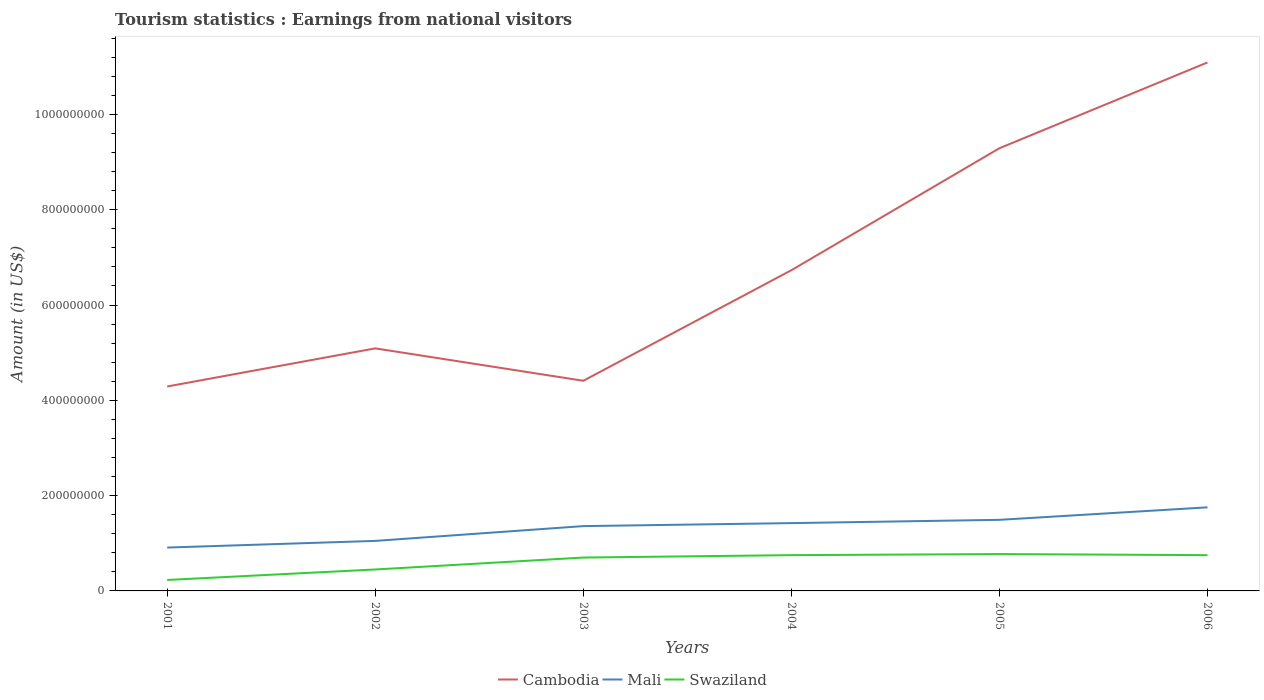Does the line corresponding to Swaziland intersect with the line corresponding to Mali?
Provide a short and direct response. No. Across all years, what is the maximum earnings from national visitors in Cambodia?
Your response must be concise. 4.29e+08. What is the total earnings from national visitors in Cambodia in the graph?
Give a very brief answer. -1.20e+07. What is the difference between the highest and the second highest earnings from national visitors in Mali?
Ensure brevity in your answer.  8.44e+07. Is the earnings from national visitors in Swaziland strictly greater than the earnings from national visitors in Cambodia over the years?
Offer a terse response. Yes. How many lines are there?
Provide a short and direct response. 3. How many years are there in the graph?
Offer a terse response. 6. How are the legend labels stacked?
Your answer should be compact. Horizontal. What is the title of the graph?
Your answer should be very brief. Tourism statistics : Earnings from national visitors. What is the Amount (in US$) in Cambodia in 2001?
Your response must be concise. 4.29e+08. What is the Amount (in US$) of Mali in 2001?
Make the answer very short. 9.10e+07. What is the Amount (in US$) in Swaziland in 2001?
Provide a succinct answer. 2.30e+07. What is the Amount (in US$) of Cambodia in 2002?
Keep it short and to the point. 5.09e+08. What is the Amount (in US$) in Mali in 2002?
Offer a terse response. 1.05e+08. What is the Amount (in US$) in Swaziland in 2002?
Make the answer very short. 4.50e+07. What is the Amount (in US$) of Cambodia in 2003?
Your answer should be compact. 4.41e+08. What is the Amount (in US$) of Mali in 2003?
Keep it short and to the point. 1.36e+08. What is the Amount (in US$) of Swaziland in 2003?
Provide a succinct answer. 7.00e+07. What is the Amount (in US$) of Cambodia in 2004?
Give a very brief answer. 6.73e+08. What is the Amount (in US$) of Mali in 2004?
Your answer should be compact. 1.42e+08. What is the Amount (in US$) of Swaziland in 2004?
Your response must be concise. 7.51e+07. What is the Amount (in US$) of Cambodia in 2005?
Your answer should be compact. 9.29e+08. What is the Amount (in US$) of Mali in 2005?
Your response must be concise. 1.49e+08. What is the Amount (in US$) in Swaziland in 2005?
Provide a succinct answer. 7.73e+07. What is the Amount (in US$) in Cambodia in 2006?
Offer a terse response. 1.11e+09. What is the Amount (in US$) in Mali in 2006?
Give a very brief answer. 1.75e+08. What is the Amount (in US$) of Swaziland in 2006?
Ensure brevity in your answer.  7.51e+07. Across all years, what is the maximum Amount (in US$) of Cambodia?
Offer a very short reply. 1.11e+09. Across all years, what is the maximum Amount (in US$) in Mali?
Your answer should be compact. 1.75e+08. Across all years, what is the maximum Amount (in US$) in Swaziland?
Your answer should be very brief. 7.73e+07. Across all years, what is the minimum Amount (in US$) of Cambodia?
Offer a very short reply. 4.29e+08. Across all years, what is the minimum Amount (in US$) in Mali?
Keep it short and to the point. 9.10e+07. Across all years, what is the minimum Amount (in US$) of Swaziland?
Your answer should be compact. 2.30e+07. What is the total Amount (in US$) of Cambodia in the graph?
Your answer should be very brief. 4.09e+09. What is the total Amount (in US$) of Mali in the graph?
Offer a very short reply. 7.99e+08. What is the total Amount (in US$) in Swaziland in the graph?
Your answer should be very brief. 3.66e+08. What is the difference between the Amount (in US$) of Cambodia in 2001 and that in 2002?
Offer a terse response. -8.00e+07. What is the difference between the Amount (in US$) of Mali in 2001 and that in 2002?
Keep it short and to the point. -1.40e+07. What is the difference between the Amount (in US$) in Swaziland in 2001 and that in 2002?
Your answer should be very brief. -2.20e+07. What is the difference between the Amount (in US$) in Cambodia in 2001 and that in 2003?
Give a very brief answer. -1.20e+07. What is the difference between the Amount (in US$) in Mali in 2001 and that in 2003?
Keep it short and to the point. -4.50e+07. What is the difference between the Amount (in US$) of Swaziland in 2001 and that in 2003?
Offer a terse response. -4.70e+07. What is the difference between the Amount (in US$) in Cambodia in 2001 and that in 2004?
Your answer should be compact. -2.44e+08. What is the difference between the Amount (in US$) in Mali in 2001 and that in 2004?
Provide a succinct answer. -5.13e+07. What is the difference between the Amount (in US$) in Swaziland in 2001 and that in 2004?
Make the answer very short. -5.21e+07. What is the difference between the Amount (in US$) in Cambodia in 2001 and that in 2005?
Offer a very short reply. -5.00e+08. What is the difference between the Amount (in US$) in Mali in 2001 and that in 2005?
Your response must be concise. -5.82e+07. What is the difference between the Amount (in US$) in Swaziland in 2001 and that in 2005?
Give a very brief answer. -5.43e+07. What is the difference between the Amount (in US$) of Cambodia in 2001 and that in 2006?
Provide a short and direct response. -6.80e+08. What is the difference between the Amount (in US$) in Mali in 2001 and that in 2006?
Your answer should be compact. -8.44e+07. What is the difference between the Amount (in US$) of Swaziland in 2001 and that in 2006?
Offer a very short reply. -5.21e+07. What is the difference between the Amount (in US$) of Cambodia in 2002 and that in 2003?
Keep it short and to the point. 6.80e+07. What is the difference between the Amount (in US$) of Mali in 2002 and that in 2003?
Make the answer very short. -3.10e+07. What is the difference between the Amount (in US$) of Swaziland in 2002 and that in 2003?
Your response must be concise. -2.50e+07. What is the difference between the Amount (in US$) in Cambodia in 2002 and that in 2004?
Your response must be concise. -1.64e+08. What is the difference between the Amount (in US$) in Mali in 2002 and that in 2004?
Provide a succinct answer. -3.73e+07. What is the difference between the Amount (in US$) of Swaziland in 2002 and that in 2004?
Provide a short and direct response. -3.01e+07. What is the difference between the Amount (in US$) of Cambodia in 2002 and that in 2005?
Give a very brief answer. -4.20e+08. What is the difference between the Amount (in US$) in Mali in 2002 and that in 2005?
Provide a short and direct response. -4.42e+07. What is the difference between the Amount (in US$) in Swaziland in 2002 and that in 2005?
Provide a succinct answer. -3.23e+07. What is the difference between the Amount (in US$) in Cambodia in 2002 and that in 2006?
Provide a succinct answer. -6.00e+08. What is the difference between the Amount (in US$) in Mali in 2002 and that in 2006?
Keep it short and to the point. -7.04e+07. What is the difference between the Amount (in US$) of Swaziland in 2002 and that in 2006?
Provide a succinct answer. -3.01e+07. What is the difference between the Amount (in US$) of Cambodia in 2003 and that in 2004?
Offer a terse response. -2.32e+08. What is the difference between the Amount (in US$) in Mali in 2003 and that in 2004?
Offer a terse response. -6.30e+06. What is the difference between the Amount (in US$) in Swaziland in 2003 and that in 2004?
Provide a short and direct response. -5.06e+06. What is the difference between the Amount (in US$) of Cambodia in 2003 and that in 2005?
Give a very brief answer. -4.88e+08. What is the difference between the Amount (in US$) in Mali in 2003 and that in 2005?
Give a very brief answer. -1.32e+07. What is the difference between the Amount (in US$) of Swaziland in 2003 and that in 2005?
Offer a very short reply. -7.26e+06. What is the difference between the Amount (in US$) of Cambodia in 2003 and that in 2006?
Provide a succinct answer. -6.68e+08. What is the difference between the Amount (in US$) in Mali in 2003 and that in 2006?
Ensure brevity in your answer.  -3.94e+07. What is the difference between the Amount (in US$) in Swaziland in 2003 and that in 2006?
Ensure brevity in your answer.  -5.06e+06. What is the difference between the Amount (in US$) of Cambodia in 2004 and that in 2005?
Your answer should be very brief. -2.56e+08. What is the difference between the Amount (in US$) in Mali in 2004 and that in 2005?
Provide a short and direct response. -6.90e+06. What is the difference between the Amount (in US$) of Swaziland in 2004 and that in 2005?
Make the answer very short. -2.20e+06. What is the difference between the Amount (in US$) in Cambodia in 2004 and that in 2006?
Offer a terse response. -4.36e+08. What is the difference between the Amount (in US$) in Mali in 2004 and that in 2006?
Ensure brevity in your answer.  -3.31e+07. What is the difference between the Amount (in US$) in Swaziland in 2004 and that in 2006?
Give a very brief answer. 0. What is the difference between the Amount (in US$) in Cambodia in 2005 and that in 2006?
Give a very brief answer. -1.80e+08. What is the difference between the Amount (in US$) in Mali in 2005 and that in 2006?
Make the answer very short. -2.62e+07. What is the difference between the Amount (in US$) in Swaziland in 2005 and that in 2006?
Your response must be concise. 2.20e+06. What is the difference between the Amount (in US$) of Cambodia in 2001 and the Amount (in US$) of Mali in 2002?
Provide a short and direct response. 3.24e+08. What is the difference between the Amount (in US$) in Cambodia in 2001 and the Amount (in US$) in Swaziland in 2002?
Your answer should be compact. 3.84e+08. What is the difference between the Amount (in US$) in Mali in 2001 and the Amount (in US$) in Swaziland in 2002?
Your answer should be very brief. 4.60e+07. What is the difference between the Amount (in US$) in Cambodia in 2001 and the Amount (in US$) in Mali in 2003?
Offer a terse response. 2.93e+08. What is the difference between the Amount (in US$) in Cambodia in 2001 and the Amount (in US$) in Swaziland in 2003?
Make the answer very short. 3.59e+08. What is the difference between the Amount (in US$) in Mali in 2001 and the Amount (in US$) in Swaziland in 2003?
Keep it short and to the point. 2.10e+07. What is the difference between the Amount (in US$) of Cambodia in 2001 and the Amount (in US$) of Mali in 2004?
Provide a succinct answer. 2.87e+08. What is the difference between the Amount (in US$) in Cambodia in 2001 and the Amount (in US$) in Swaziland in 2004?
Provide a succinct answer. 3.54e+08. What is the difference between the Amount (in US$) of Mali in 2001 and the Amount (in US$) of Swaziland in 2004?
Your response must be concise. 1.59e+07. What is the difference between the Amount (in US$) of Cambodia in 2001 and the Amount (in US$) of Mali in 2005?
Give a very brief answer. 2.80e+08. What is the difference between the Amount (in US$) in Cambodia in 2001 and the Amount (in US$) in Swaziland in 2005?
Your answer should be compact. 3.52e+08. What is the difference between the Amount (in US$) of Mali in 2001 and the Amount (in US$) of Swaziland in 2005?
Your response must be concise. 1.37e+07. What is the difference between the Amount (in US$) in Cambodia in 2001 and the Amount (in US$) in Mali in 2006?
Give a very brief answer. 2.54e+08. What is the difference between the Amount (in US$) in Cambodia in 2001 and the Amount (in US$) in Swaziland in 2006?
Make the answer very short. 3.54e+08. What is the difference between the Amount (in US$) in Mali in 2001 and the Amount (in US$) in Swaziland in 2006?
Offer a very short reply. 1.59e+07. What is the difference between the Amount (in US$) of Cambodia in 2002 and the Amount (in US$) of Mali in 2003?
Keep it short and to the point. 3.73e+08. What is the difference between the Amount (in US$) in Cambodia in 2002 and the Amount (in US$) in Swaziland in 2003?
Ensure brevity in your answer.  4.39e+08. What is the difference between the Amount (in US$) in Mali in 2002 and the Amount (in US$) in Swaziland in 2003?
Provide a short and direct response. 3.50e+07. What is the difference between the Amount (in US$) in Cambodia in 2002 and the Amount (in US$) in Mali in 2004?
Your answer should be compact. 3.67e+08. What is the difference between the Amount (in US$) in Cambodia in 2002 and the Amount (in US$) in Swaziland in 2004?
Give a very brief answer. 4.34e+08. What is the difference between the Amount (in US$) in Mali in 2002 and the Amount (in US$) in Swaziland in 2004?
Offer a terse response. 2.99e+07. What is the difference between the Amount (in US$) of Cambodia in 2002 and the Amount (in US$) of Mali in 2005?
Your response must be concise. 3.60e+08. What is the difference between the Amount (in US$) in Cambodia in 2002 and the Amount (in US$) in Swaziland in 2005?
Ensure brevity in your answer.  4.32e+08. What is the difference between the Amount (in US$) of Mali in 2002 and the Amount (in US$) of Swaziland in 2005?
Offer a terse response. 2.77e+07. What is the difference between the Amount (in US$) of Cambodia in 2002 and the Amount (in US$) of Mali in 2006?
Your answer should be compact. 3.34e+08. What is the difference between the Amount (in US$) of Cambodia in 2002 and the Amount (in US$) of Swaziland in 2006?
Offer a very short reply. 4.34e+08. What is the difference between the Amount (in US$) in Mali in 2002 and the Amount (in US$) in Swaziland in 2006?
Ensure brevity in your answer.  2.99e+07. What is the difference between the Amount (in US$) in Cambodia in 2003 and the Amount (in US$) in Mali in 2004?
Offer a terse response. 2.99e+08. What is the difference between the Amount (in US$) in Cambodia in 2003 and the Amount (in US$) in Swaziland in 2004?
Provide a short and direct response. 3.66e+08. What is the difference between the Amount (in US$) of Mali in 2003 and the Amount (in US$) of Swaziland in 2004?
Your answer should be compact. 6.09e+07. What is the difference between the Amount (in US$) in Cambodia in 2003 and the Amount (in US$) in Mali in 2005?
Your response must be concise. 2.92e+08. What is the difference between the Amount (in US$) in Cambodia in 2003 and the Amount (in US$) in Swaziland in 2005?
Your response must be concise. 3.64e+08. What is the difference between the Amount (in US$) in Mali in 2003 and the Amount (in US$) in Swaziland in 2005?
Ensure brevity in your answer.  5.87e+07. What is the difference between the Amount (in US$) in Cambodia in 2003 and the Amount (in US$) in Mali in 2006?
Offer a very short reply. 2.66e+08. What is the difference between the Amount (in US$) of Cambodia in 2003 and the Amount (in US$) of Swaziland in 2006?
Ensure brevity in your answer.  3.66e+08. What is the difference between the Amount (in US$) of Mali in 2003 and the Amount (in US$) of Swaziland in 2006?
Your response must be concise. 6.09e+07. What is the difference between the Amount (in US$) in Cambodia in 2004 and the Amount (in US$) in Mali in 2005?
Keep it short and to the point. 5.24e+08. What is the difference between the Amount (in US$) in Cambodia in 2004 and the Amount (in US$) in Swaziland in 2005?
Give a very brief answer. 5.96e+08. What is the difference between the Amount (in US$) of Mali in 2004 and the Amount (in US$) of Swaziland in 2005?
Your answer should be compact. 6.50e+07. What is the difference between the Amount (in US$) in Cambodia in 2004 and the Amount (in US$) in Mali in 2006?
Offer a terse response. 4.98e+08. What is the difference between the Amount (in US$) of Cambodia in 2004 and the Amount (in US$) of Swaziland in 2006?
Your answer should be very brief. 5.98e+08. What is the difference between the Amount (in US$) in Mali in 2004 and the Amount (in US$) in Swaziland in 2006?
Offer a very short reply. 6.72e+07. What is the difference between the Amount (in US$) of Cambodia in 2005 and the Amount (in US$) of Mali in 2006?
Your response must be concise. 7.54e+08. What is the difference between the Amount (in US$) in Cambodia in 2005 and the Amount (in US$) in Swaziland in 2006?
Provide a succinct answer. 8.54e+08. What is the difference between the Amount (in US$) of Mali in 2005 and the Amount (in US$) of Swaziland in 2006?
Your answer should be compact. 7.41e+07. What is the average Amount (in US$) of Cambodia per year?
Offer a terse response. 6.82e+08. What is the average Amount (in US$) of Mali per year?
Offer a very short reply. 1.33e+08. What is the average Amount (in US$) of Swaziland per year?
Your answer should be compact. 6.09e+07. In the year 2001, what is the difference between the Amount (in US$) in Cambodia and Amount (in US$) in Mali?
Your answer should be very brief. 3.38e+08. In the year 2001, what is the difference between the Amount (in US$) of Cambodia and Amount (in US$) of Swaziland?
Provide a short and direct response. 4.06e+08. In the year 2001, what is the difference between the Amount (in US$) of Mali and Amount (in US$) of Swaziland?
Offer a very short reply. 6.80e+07. In the year 2002, what is the difference between the Amount (in US$) of Cambodia and Amount (in US$) of Mali?
Provide a succinct answer. 4.04e+08. In the year 2002, what is the difference between the Amount (in US$) in Cambodia and Amount (in US$) in Swaziland?
Offer a terse response. 4.64e+08. In the year 2002, what is the difference between the Amount (in US$) of Mali and Amount (in US$) of Swaziland?
Give a very brief answer. 6.00e+07. In the year 2003, what is the difference between the Amount (in US$) of Cambodia and Amount (in US$) of Mali?
Provide a short and direct response. 3.05e+08. In the year 2003, what is the difference between the Amount (in US$) of Cambodia and Amount (in US$) of Swaziland?
Your answer should be very brief. 3.71e+08. In the year 2003, what is the difference between the Amount (in US$) in Mali and Amount (in US$) in Swaziland?
Keep it short and to the point. 6.60e+07. In the year 2004, what is the difference between the Amount (in US$) of Cambodia and Amount (in US$) of Mali?
Provide a succinct answer. 5.31e+08. In the year 2004, what is the difference between the Amount (in US$) of Cambodia and Amount (in US$) of Swaziland?
Ensure brevity in your answer.  5.98e+08. In the year 2004, what is the difference between the Amount (in US$) in Mali and Amount (in US$) in Swaziland?
Provide a short and direct response. 6.72e+07. In the year 2005, what is the difference between the Amount (in US$) in Cambodia and Amount (in US$) in Mali?
Keep it short and to the point. 7.80e+08. In the year 2005, what is the difference between the Amount (in US$) in Cambodia and Amount (in US$) in Swaziland?
Your response must be concise. 8.52e+08. In the year 2005, what is the difference between the Amount (in US$) of Mali and Amount (in US$) of Swaziland?
Make the answer very short. 7.19e+07. In the year 2006, what is the difference between the Amount (in US$) in Cambodia and Amount (in US$) in Mali?
Keep it short and to the point. 9.34e+08. In the year 2006, what is the difference between the Amount (in US$) of Cambodia and Amount (in US$) of Swaziland?
Offer a very short reply. 1.03e+09. In the year 2006, what is the difference between the Amount (in US$) of Mali and Amount (in US$) of Swaziland?
Ensure brevity in your answer.  1.00e+08. What is the ratio of the Amount (in US$) in Cambodia in 2001 to that in 2002?
Offer a very short reply. 0.84. What is the ratio of the Amount (in US$) of Mali in 2001 to that in 2002?
Your response must be concise. 0.87. What is the ratio of the Amount (in US$) of Swaziland in 2001 to that in 2002?
Make the answer very short. 0.51. What is the ratio of the Amount (in US$) of Cambodia in 2001 to that in 2003?
Provide a short and direct response. 0.97. What is the ratio of the Amount (in US$) of Mali in 2001 to that in 2003?
Keep it short and to the point. 0.67. What is the ratio of the Amount (in US$) of Swaziland in 2001 to that in 2003?
Offer a terse response. 0.33. What is the ratio of the Amount (in US$) in Cambodia in 2001 to that in 2004?
Provide a short and direct response. 0.64. What is the ratio of the Amount (in US$) in Mali in 2001 to that in 2004?
Your response must be concise. 0.64. What is the ratio of the Amount (in US$) in Swaziland in 2001 to that in 2004?
Offer a terse response. 0.31. What is the ratio of the Amount (in US$) of Cambodia in 2001 to that in 2005?
Ensure brevity in your answer.  0.46. What is the ratio of the Amount (in US$) in Mali in 2001 to that in 2005?
Make the answer very short. 0.61. What is the ratio of the Amount (in US$) in Swaziland in 2001 to that in 2005?
Offer a very short reply. 0.3. What is the ratio of the Amount (in US$) of Cambodia in 2001 to that in 2006?
Ensure brevity in your answer.  0.39. What is the ratio of the Amount (in US$) of Mali in 2001 to that in 2006?
Your answer should be compact. 0.52. What is the ratio of the Amount (in US$) in Swaziland in 2001 to that in 2006?
Give a very brief answer. 0.31. What is the ratio of the Amount (in US$) of Cambodia in 2002 to that in 2003?
Keep it short and to the point. 1.15. What is the ratio of the Amount (in US$) of Mali in 2002 to that in 2003?
Your answer should be compact. 0.77. What is the ratio of the Amount (in US$) in Swaziland in 2002 to that in 2003?
Offer a very short reply. 0.64. What is the ratio of the Amount (in US$) of Cambodia in 2002 to that in 2004?
Keep it short and to the point. 0.76. What is the ratio of the Amount (in US$) of Mali in 2002 to that in 2004?
Ensure brevity in your answer.  0.74. What is the ratio of the Amount (in US$) of Swaziland in 2002 to that in 2004?
Provide a short and direct response. 0.6. What is the ratio of the Amount (in US$) in Cambodia in 2002 to that in 2005?
Ensure brevity in your answer.  0.55. What is the ratio of the Amount (in US$) of Mali in 2002 to that in 2005?
Your answer should be compact. 0.7. What is the ratio of the Amount (in US$) of Swaziland in 2002 to that in 2005?
Give a very brief answer. 0.58. What is the ratio of the Amount (in US$) in Cambodia in 2002 to that in 2006?
Your answer should be compact. 0.46. What is the ratio of the Amount (in US$) of Mali in 2002 to that in 2006?
Offer a very short reply. 0.6. What is the ratio of the Amount (in US$) of Swaziland in 2002 to that in 2006?
Offer a terse response. 0.6. What is the ratio of the Amount (in US$) in Cambodia in 2003 to that in 2004?
Keep it short and to the point. 0.66. What is the ratio of the Amount (in US$) in Mali in 2003 to that in 2004?
Ensure brevity in your answer.  0.96. What is the ratio of the Amount (in US$) of Swaziland in 2003 to that in 2004?
Make the answer very short. 0.93. What is the ratio of the Amount (in US$) in Cambodia in 2003 to that in 2005?
Give a very brief answer. 0.47. What is the ratio of the Amount (in US$) of Mali in 2003 to that in 2005?
Your answer should be compact. 0.91. What is the ratio of the Amount (in US$) of Swaziland in 2003 to that in 2005?
Make the answer very short. 0.91. What is the ratio of the Amount (in US$) of Cambodia in 2003 to that in 2006?
Make the answer very short. 0.4. What is the ratio of the Amount (in US$) of Mali in 2003 to that in 2006?
Give a very brief answer. 0.78. What is the ratio of the Amount (in US$) in Swaziland in 2003 to that in 2006?
Provide a succinct answer. 0.93. What is the ratio of the Amount (in US$) in Cambodia in 2004 to that in 2005?
Provide a short and direct response. 0.72. What is the ratio of the Amount (in US$) of Mali in 2004 to that in 2005?
Keep it short and to the point. 0.95. What is the ratio of the Amount (in US$) of Swaziland in 2004 to that in 2005?
Your answer should be compact. 0.97. What is the ratio of the Amount (in US$) of Cambodia in 2004 to that in 2006?
Offer a terse response. 0.61. What is the ratio of the Amount (in US$) in Mali in 2004 to that in 2006?
Provide a succinct answer. 0.81. What is the ratio of the Amount (in US$) of Cambodia in 2005 to that in 2006?
Offer a terse response. 0.84. What is the ratio of the Amount (in US$) in Mali in 2005 to that in 2006?
Your answer should be very brief. 0.85. What is the ratio of the Amount (in US$) in Swaziland in 2005 to that in 2006?
Your response must be concise. 1.03. What is the difference between the highest and the second highest Amount (in US$) in Cambodia?
Your response must be concise. 1.80e+08. What is the difference between the highest and the second highest Amount (in US$) of Mali?
Offer a very short reply. 2.62e+07. What is the difference between the highest and the second highest Amount (in US$) in Swaziland?
Offer a very short reply. 2.20e+06. What is the difference between the highest and the lowest Amount (in US$) in Cambodia?
Your answer should be very brief. 6.80e+08. What is the difference between the highest and the lowest Amount (in US$) in Mali?
Ensure brevity in your answer.  8.44e+07. What is the difference between the highest and the lowest Amount (in US$) in Swaziland?
Your answer should be very brief. 5.43e+07. 